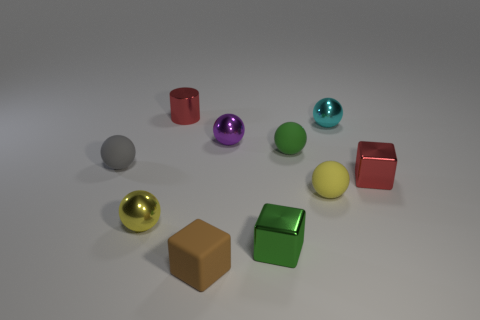Subtract 3 spheres. How many spheres are left? 3 Subtract all green balls. How many balls are left? 5 Subtract all yellow spheres. How many spheres are left? 4 Subtract all blue balls. Subtract all red cylinders. How many balls are left? 6 Subtract all balls. How many objects are left? 4 Add 4 purple metal balls. How many purple metal balls are left? 5 Add 5 brown blocks. How many brown blocks exist? 6 Subtract 1 green balls. How many objects are left? 9 Subtract all big gray matte cubes. Subtract all tiny purple shiny things. How many objects are left? 9 